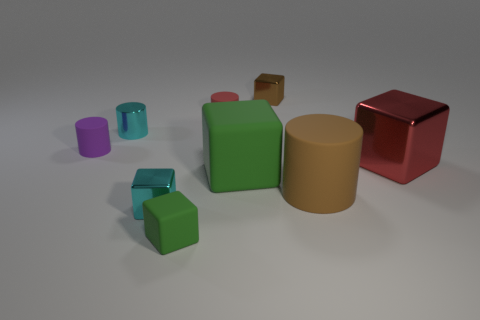What number of other objects are there of the same size as the brown cylinder?
Your response must be concise. 2. Is the large matte block the same color as the small rubber block?
Your response must be concise. Yes. There is a tiny metal object that is in front of the small rubber cylinder that is in front of the tiny matte cylinder behind the small purple thing; what is its color?
Provide a succinct answer. Cyan. There is a large cube that is left of the metal block behind the red metal object; what number of things are behind it?
Keep it short and to the point. 5. Is there anything else of the same color as the metallic cylinder?
Offer a terse response. Yes. Does the green matte object in front of the brown cylinder have the same size as the big red block?
Your answer should be very brief. No. There is a tiny rubber cylinder right of the purple object; how many tiny brown metal blocks are in front of it?
Your answer should be compact. 0. Is there a red object that is behind the tiny matte thing left of the green rubber object that is left of the small red cylinder?
Keep it short and to the point. Yes. There is a tiny purple thing that is the same shape as the red matte thing; what material is it?
Ensure brevity in your answer.  Rubber. Is the material of the big cylinder the same as the brown thing behind the purple rubber cylinder?
Offer a very short reply. No. 